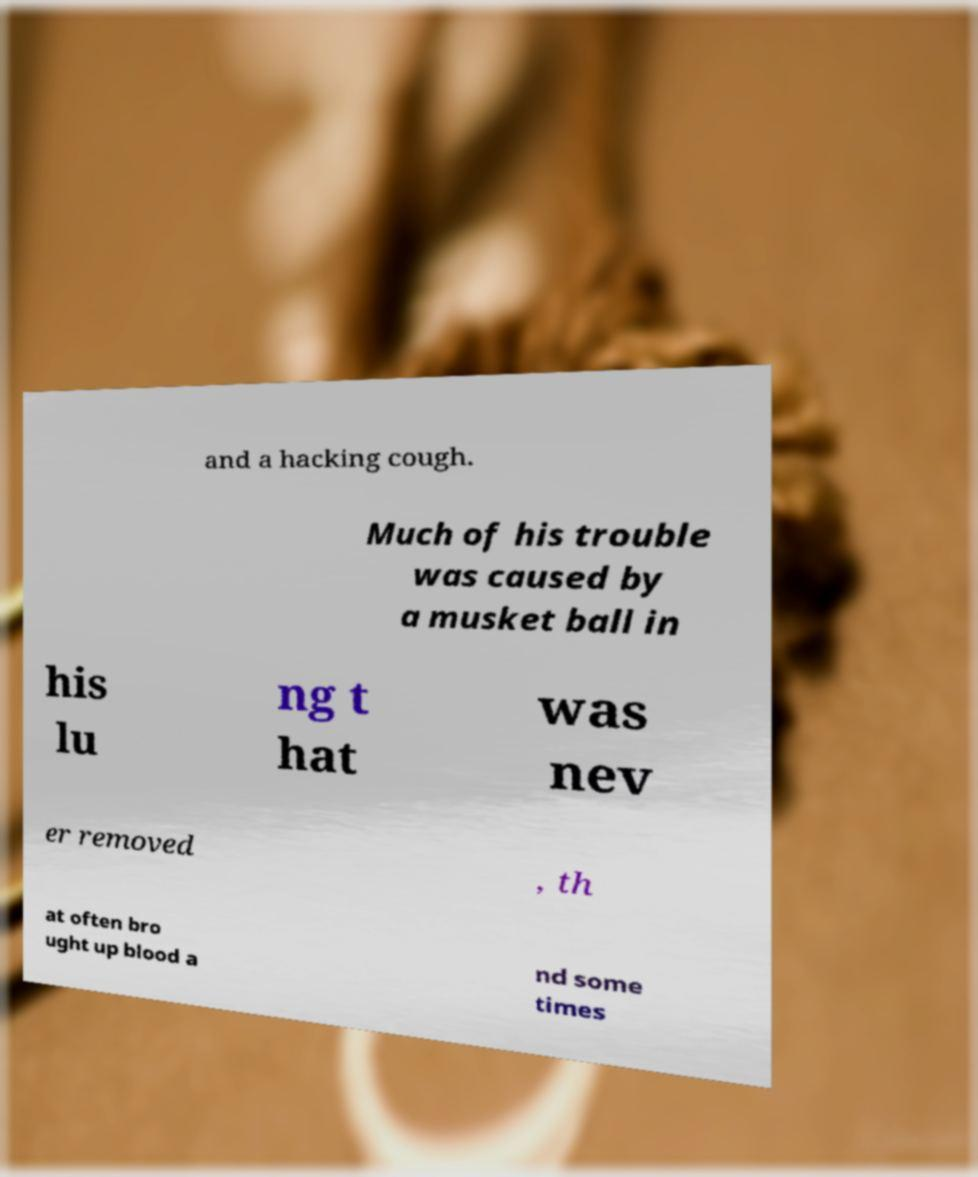Could you extract and type out the text from this image? and a hacking cough. Much of his trouble was caused by a musket ball in his lu ng t hat was nev er removed , th at often bro ught up blood a nd some times 